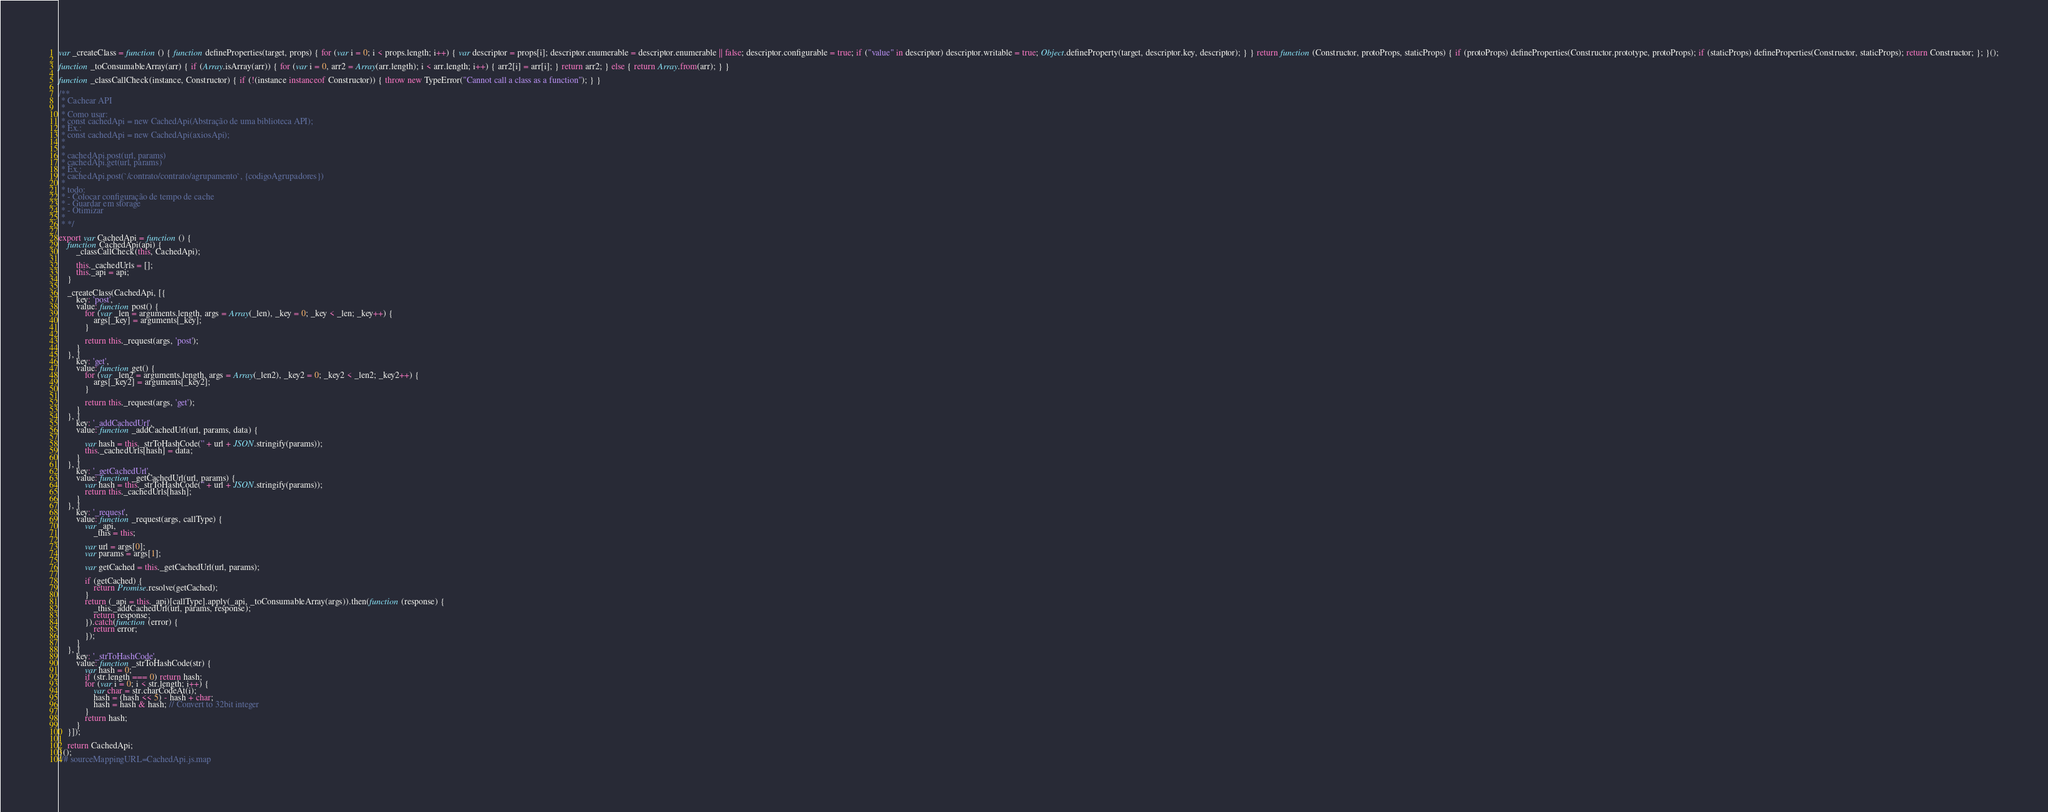Convert code to text. <code><loc_0><loc_0><loc_500><loc_500><_JavaScript_>var _createClass = function () { function defineProperties(target, props) { for (var i = 0; i < props.length; i++) { var descriptor = props[i]; descriptor.enumerable = descriptor.enumerable || false; descriptor.configurable = true; if ("value" in descriptor) descriptor.writable = true; Object.defineProperty(target, descriptor.key, descriptor); } } return function (Constructor, protoProps, staticProps) { if (protoProps) defineProperties(Constructor.prototype, protoProps); if (staticProps) defineProperties(Constructor, staticProps); return Constructor; }; }();

function _toConsumableArray(arr) { if (Array.isArray(arr)) { for (var i = 0, arr2 = Array(arr.length); i < arr.length; i++) { arr2[i] = arr[i]; } return arr2; } else { return Array.from(arr); } }

function _classCallCheck(instance, Constructor) { if (!(instance instanceof Constructor)) { throw new TypeError("Cannot call a class as a function"); } }

/**
 * Cachear API
 *
 * Como usar:
 * const cachedApi = new CachedApi(Abstração de uma biblioteca API);
 * Ex.:
 * const cachedApi = new CachedApi(axiosApi);
 *
 *
 * cachedApi.post(url, params)
 * cachedApi.get(url, params)
 * Ex.:
 * cachedApi.post(`/contrato/contrato/agrupamento`, {codigoAgrupadores})
 *
 * todo:
 * - Colocar configuração de tempo de cache
 * - Guardar em storage
 * - Otimizar
 *
 * */

export var CachedApi = function () {
    function CachedApi(api) {
        _classCallCheck(this, CachedApi);

        this._cachedUrls = [];
        this._api = api;
    }

    _createClass(CachedApi, [{
        key: 'post',
        value: function post() {
            for (var _len = arguments.length, args = Array(_len), _key = 0; _key < _len; _key++) {
                args[_key] = arguments[_key];
            }

            return this._request(args, 'post');
        }
    }, {
        key: 'get',
        value: function get() {
            for (var _len2 = arguments.length, args = Array(_len2), _key2 = 0; _key2 < _len2; _key2++) {
                args[_key2] = arguments[_key2];
            }

            return this._request(args, 'get');
        }
    }, {
        key: '_addCachedUrl',
        value: function _addCachedUrl(url, params, data) {

            var hash = this._strToHashCode('' + url + JSON.stringify(params));
            this._cachedUrls[hash] = data;
        }
    }, {
        key: '_getCachedUrl',
        value: function _getCachedUrl(url, params) {
            var hash = this._strToHashCode('' + url + JSON.stringify(params));
            return this._cachedUrls[hash];
        }
    }, {
        key: '_request',
        value: function _request(args, callType) {
            var _api,
                _this = this;

            var url = args[0];
            var params = args[1];

            var getCached = this._getCachedUrl(url, params);

            if (getCached) {
                return Promise.resolve(getCached);
            }
            return (_api = this._api)[callType].apply(_api, _toConsumableArray(args)).then(function (response) {
                _this._addCachedUrl(url, params, response);
                return response;
            }).catch(function (error) {
                return error;
            });
        }
    }, {
        key: '_strToHashCode',
        value: function _strToHashCode(str) {
            var hash = 0;
            if (str.length === 0) return hash;
            for (var i = 0; i < str.length; i++) {
                var char = str.charCodeAt(i);
                hash = (hash << 5) - hash + char;
                hash = hash & hash; // Convert to 32bit integer
            }
            return hash;
        }
    }]);

    return CachedApi;
}();
//# sourceMappingURL=CachedApi.js.map</code> 